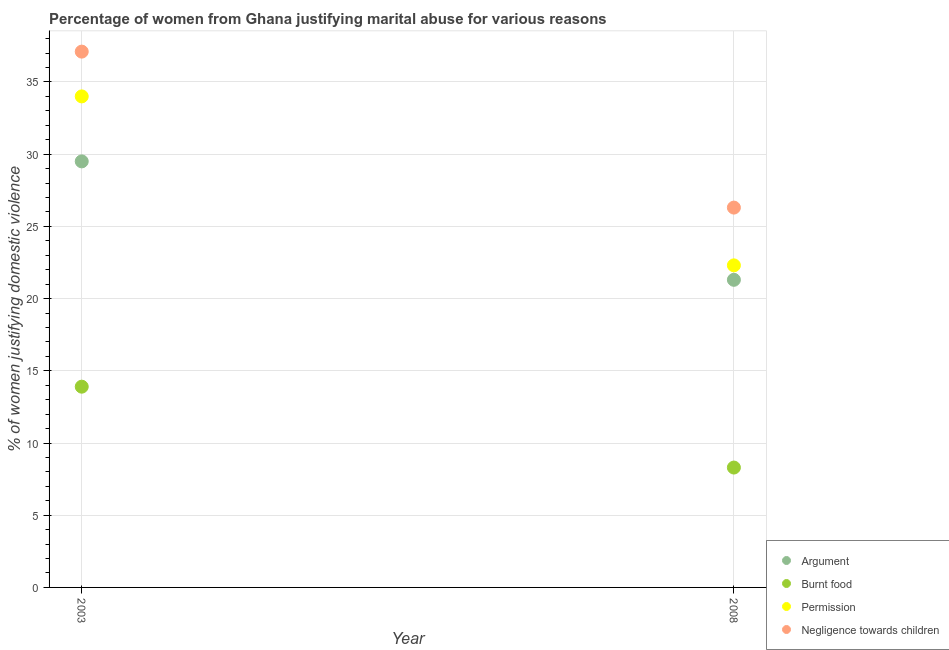Is the number of dotlines equal to the number of legend labels?
Provide a short and direct response. Yes. Across all years, what is the maximum percentage of women justifying abuse in the case of an argument?
Keep it short and to the point. 29.5. Across all years, what is the minimum percentage of women justifying abuse for showing negligence towards children?
Give a very brief answer. 26.3. In which year was the percentage of women justifying abuse for showing negligence towards children minimum?
Offer a terse response. 2008. What is the total percentage of women justifying abuse for going without permission in the graph?
Provide a short and direct response. 56.3. What is the average percentage of women justifying abuse in the case of an argument per year?
Your answer should be very brief. 25.4. In the year 2003, what is the difference between the percentage of women justifying abuse in the case of an argument and percentage of women justifying abuse for showing negligence towards children?
Keep it short and to the point. -7.6. In how many years, is the percentage of women justifying abuse for going without permission greater than 30 %?
Ensure brevity in your answer.  1. What is the ratio of the percentage of women justifying abuse for burning food in 2003 to that in 2008?
Ensure brevity in your answer.  1.67. Is it the case that in every year, the sum of the percentage of women justifying abuse in the case of an argument and percentage of women justifying abuse for showing negligence towards children is greater than the sum of percentage of women justifying abuse for burning food and percentage of women justifying abuse for going without permission?
Your response must be concise. No. Is it the case that in every year, the sum of the percentage of women justifying abuse in the case of an argument and percentage of women justifying abuse for burning food is greater than the percentage of women justifying abuse for going without permission?
Provide a short and direct response. Yes. Does the percentage of women justifying abuse in the case of an argument monotonically increase over the years?
Ensure brevity in your answer.  No. Is the percentage of women justifying abuse for showing negligence towards children strictly greater than the percentage of women justifying abuse for going without permission over the years?
Keep it short and to the point. Yes. Is the percentage of women justifying abuse for showing negligence towards children strictly less than the percentage of women justifying abuse in the case of an argument over the years?
Provide a short and direct response. No. Does the graph contain any zero values?
Your answer should be very brief. No. Does the graph contain grids?
Offer a terse response. Yes. Where does the legend appear in the graph?
Your response must be concise. Bottom right. What is the title of the graph?
Offer a very short reply. Percentage of women from Ghana justifying marital abuse for various reasons. What is the label or title of the Y-axis?
Give a very brief answer. % of women justifying domestic violence. What is the % of women justifying domestic violence in Argument in 2003?
Offer a terse response. 29.5. What is the % of women justifying domestic violence in Burnt food in 2003?
Offer a terse response. 13.9. What is the % of women justifying domestic violence of Negligence towards children in 2003?
Keep it short and to the point. 37.1. What is the % of women justifying domestic violence of Argument in 2008?
Keep it short and to the point. 21.3. What is the % of women justifying domestic violence of Permission in 2008?
Your answer should be very brief. 22.3. What is the % of women justifying domestic violence of Negligence towards children in 2008?
Provide a succinct answer. 26.3. Across all years, what is the maximum % of women justifying domestic violence in Argument?
Your response must be concise. 29.5. Across all years, what is the maximum % of women justifying domestic violence of Burnt food?
Keep it short and to the point. 13.9. Across all years, what is the maximum % of women justifying domestic violence of Negligence towards children?
Make the answer very short. 37.1. Across all years, what is the minimum % of women justifying domestic violence of Argument?
Your response must be concise. 21.3. Across all years, what is the minimum % of women justifying domestic violence in Permission?
Your answer should be very brief. 22.3. Across all years, what is the minimum % of women justifying domestic violence in Negligence towards children?
Keep it short and to the point. 26.3. What is the total % of women justifying domestic violence in Argument in the graph?
Your answer should be very brief. 50.8. What is the total % of women justifying domestic violence in Burnt food in the graph?
Your answer should be very brief. 22.2. What is the total % of women justifying domestic violence of Permission in the graph?
Give a very brief answer. 56.3. What is the total % of women justifying domestic violence in Negligence towards children in the graph?
Provide a short and direct response. 63.4. What is the difference between the % of women justifying domestic violence in Argument in 2003 and that in 2008?
Offer a very short reply. 8.2. What is the difference between the % of women justifying domestic violence of Permission in 2003 and that in 2008?
Offer a very short reply. 11.7. What is the difference between the % of women justifying domestic violence of Argument in 2003 and the % of women justifying domestic violence of Burnt food in 2008?
Your response must be concise. 21.2. What is the difference between the % of women justifying domestic violence of Argument in 2003 and the % of women justifying domestic violence of Permission in 2008?
Ensure brevity in your answer.  7.2. What is the difference between the % of women justifying domestic violence of Argument in 2003 and the % of women justifying domestic violence of Negligence towards children in 2008?
Make the answer very short. 3.2. What is the difference between the % of women justifying domestic violence of Burnt food in 2003 and the % of women justifying domestic violence of Negligence towards children in 2008?
Make the answer very short. -12.4. What is the average % of women justifying domestic violence in Argument per year?
Provide a succinct answer. 25.4. What is the average % of women justifying domestic violence in Burnt food per year?
Provide a succinct answer. 11.1. What is the average % of women justifying domestic violence of Permission per year?
Give a very brief answer. 28.15. What is the average % of women justifying domestic violence in Negligence towards children per year?
Give a very brief answer. 31.7. In the year 2003, what is the difference between the % of women justifying domestic violence of Argument and % of women justifying domestic violence of Burnt food?
Offer a very short reply. 15.6. In the year 2003, what is the difference between the % of women justifying domestic violence in Burnt food and % of women justifying domestic violence in Permission?
Ensure brevity in your answer.  -20.1. In the year 2003, what is the difference between the % of women justifying domestic violence in Burnt food and % of women justifying domestic violence in Negligence towards children?
Your answer should be very brief. -23.2. In the year 2003, what is the difference between the % of women justifying domestic violence of Permission and % of women justifying domestic violence of Negligence towards children?
Your response must be concise. -3.1. In the year 2008, what is the difference between the % of women justifying domestic violence in Argument and % of women justifying domestic violence in Burnt food?
Make the answer very short. 13. In the year 2008, what is the difference between the % of women justifying domestic violence in Argument and % of women justifying domestic violence in Negligence towards children?
Make the answer very short. -5. What is the ratio of the % of women justifying domestic violence of Argument in 2003 to that in 2008?
Your response must be concise. 1.39. What is the ratio of the % of women justifying domestic violence of Burnt food in 2003 to that in 2008?
Provide a succinct answer. 1.67. What is the ratio of the % of women justifying domestic violence of Permission in 2003 to that in 2008?
Offer a terse response. 1.52. What is the ratio of the % of women justifying domestic violence in Negligence towards children in 2003 to that in 2008?
Provide a succinct answer. 1.41. What is the difference between the highest and the second highest % of women justifying domestic violence of Burnt food?
Give a very brief answer. 5.6. What is the difference between the highest and the second highest % of women justifying domestic violence in Negligence towards children?
Offer a terse response. 10.8. 